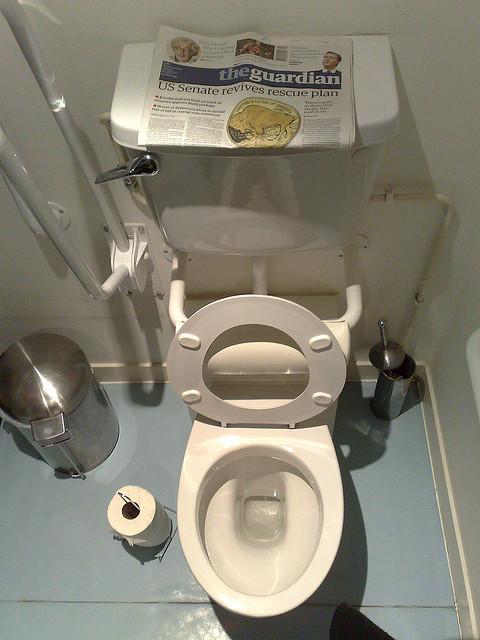What does the paper say on the blue border?
Quick response, please. Guardian. Where is the toilet paper?
Be succinct. On floor. Is the toilet clean?
Concise answer only. Yes. 